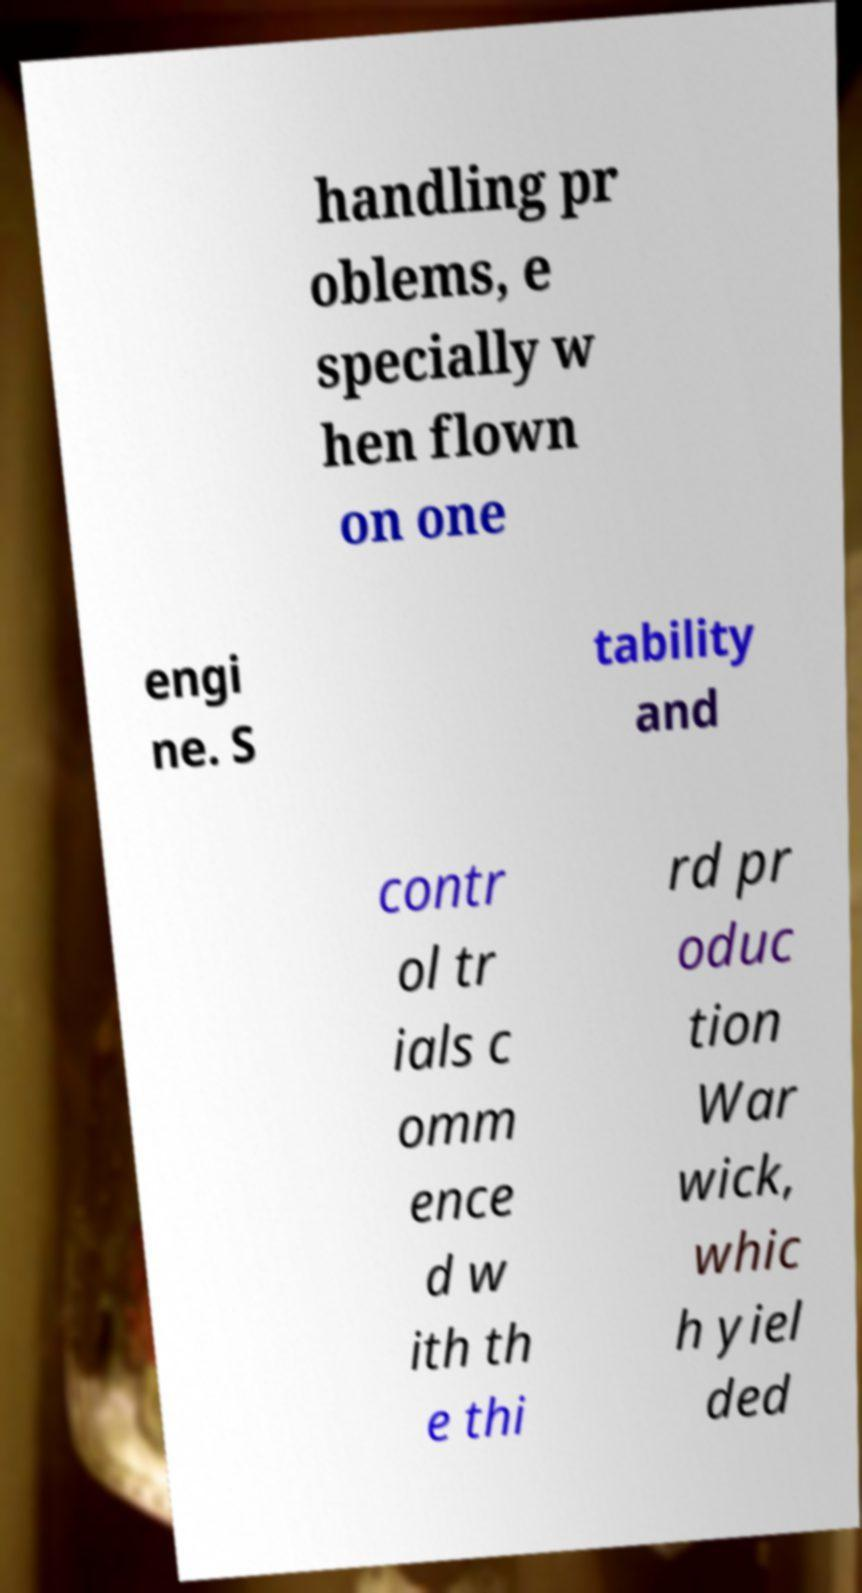Can you read and provide the text displayed in the image?This photo seems to have some interesting text. Can you extract and type it out for me? handling pr oblems, e specially w hen flown on one engi ne. S tability and contr ol tr ials c omm ence d w ith th e thi rd pr oduc tion War wick, whic h yiel ded 